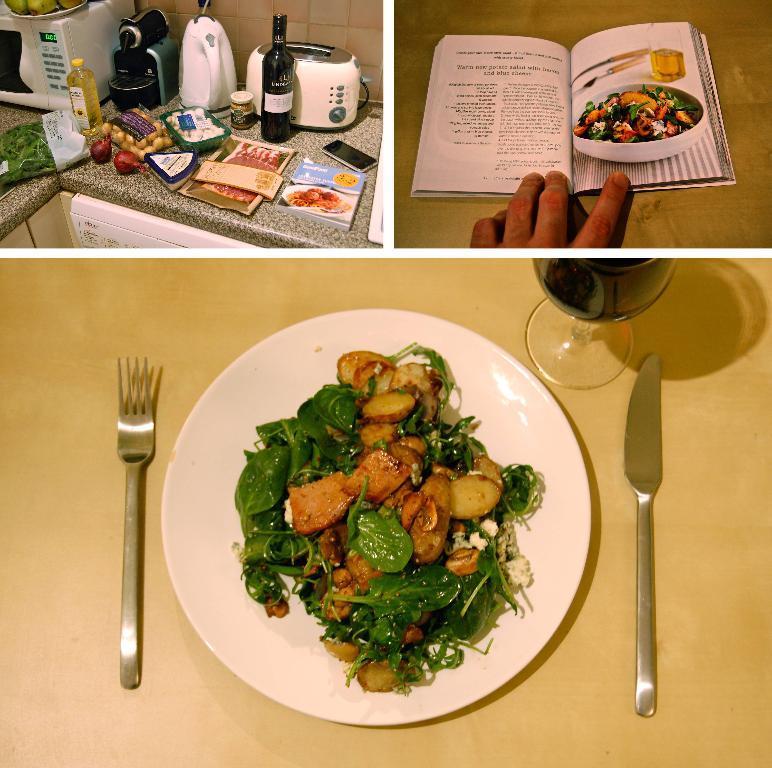Can you describe this image briefly? This is a collage image. I can see a plate with a food item, knife, fork and wine glass on the table. At the top right side of the image, I can see the fingers of a person and a book on a wooden board. At the top left side of the image, there is a micro oven, toaster, bottles, vegetables, book, mobile phone and few other things on an object. 